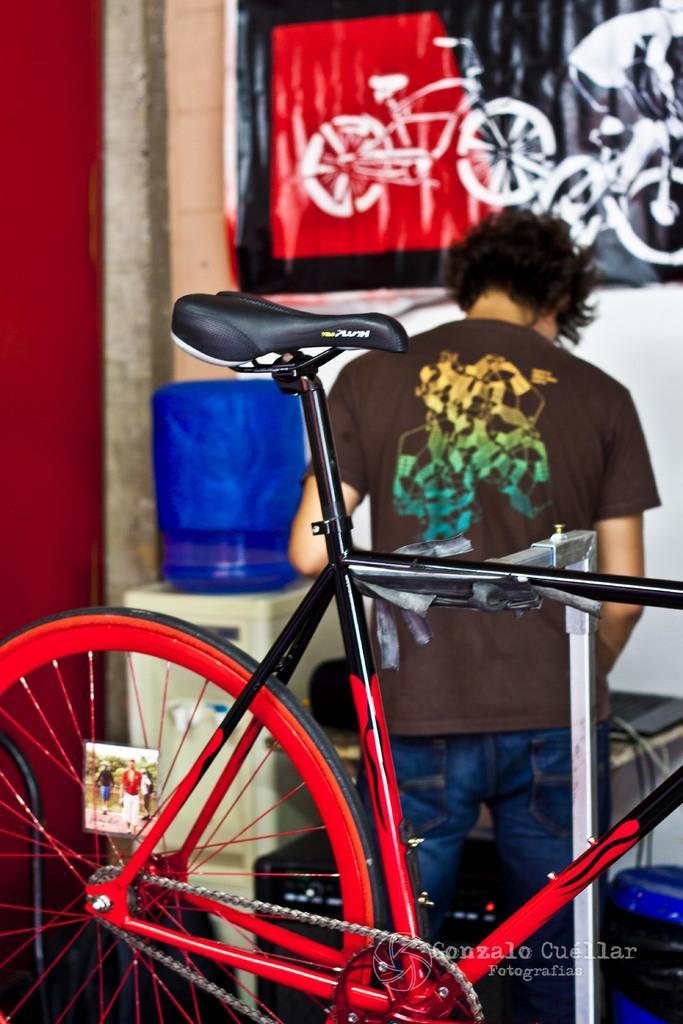Describe this image in one or two sentences. In this picture there is a bicycle and there is a person standing beside it and there is a water filter and a table which has few on it is in front of him and there is a painting on the wall in the background. 